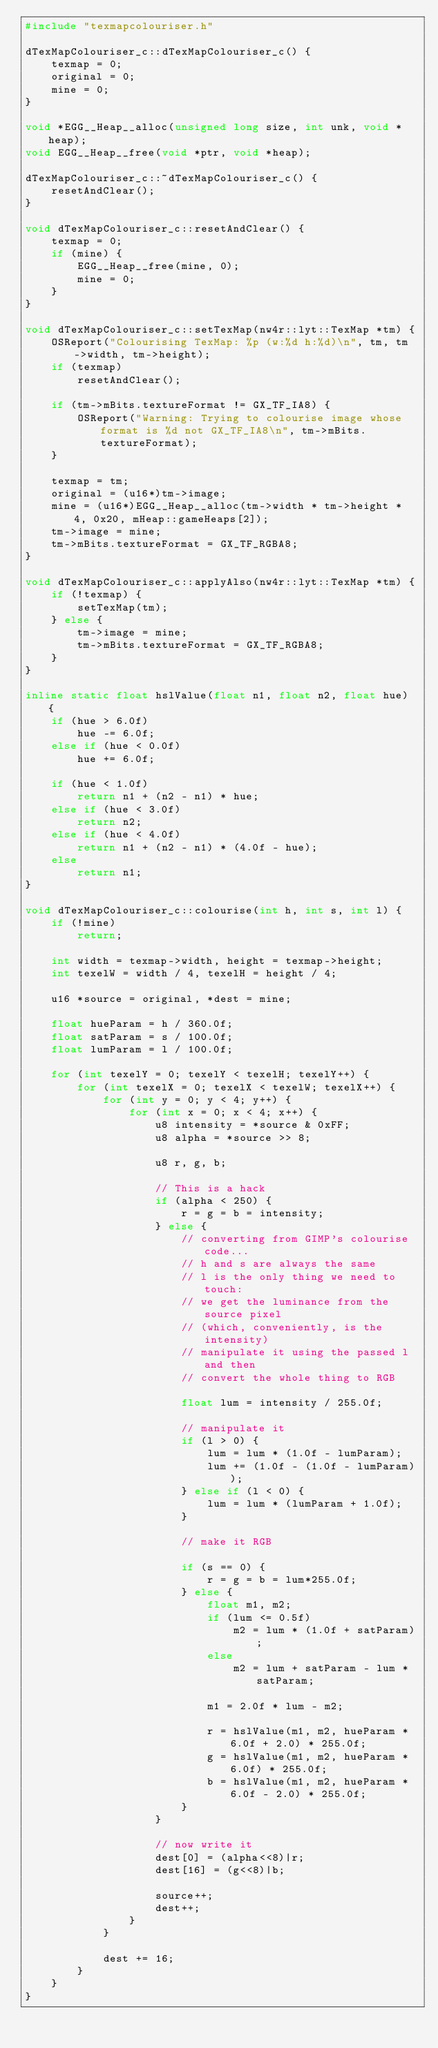<code> <loc_0><loc_0><loc_500><loc_500><_C++_>#include "texmapcolouriser.h"

dTexMapColouriser_c::dTexMapColouriser_c() {
	texmap = 0;
	original = 0;
	mine = 0;
}

void *EGG__Heap__alloc(unsigned long size, int unk, void *heap);
void EGG__Heap__free(void *ptr, void *heap);

dTexMapColouriser_c::~dTexMapColouriser_c() {
	resetAndClear();
}

void dTexMapColouriser_c::resetAndClear() {
	texmap = 0;
	if (mine) {
		EGG__Heap__free(mine, 0);
		mine = 0;
	}
}

void dTexMapColouriser_c::setTexMap(nw4r::lyt::TexMap *tm) {
	OSReport("Colourising TexMap: %p (w:%d h:%d)\n", tm, tm->width, tm->height);
	if (texmap)
		resetAndClear();

	if (tm->mBits.textureFormat != GX_TF_IA8) {
		OSReport("Warning: Trying to colourise image whose format is %d not GX_TF_IA8\n", tm->mBits.textureFormat);
	}

	texmap = tm;
	original = (u16*)tm->image;
	mine = (u16*)EGG__Heap__alloc(tm->width * tm->height * 4, 0x20, mHeap::gameHeaps[2]);
	tm->image = mine;
	tm->mBits.textureFormat = GX_TF_RGBA8;
}

void dTexMapColouriser_c::applyAlso(nw4r::lyt::TexMap *tm) {
	if (!texmap) {
		setTexMap(tm);
	} else {
		tm->image = mine;
		tm->mBits.textureFormat = GX_TF_RGBA8;
	}
}

inline static float hslValue(float n1, float n2, float hue) {
	if (hue > 6.0f)
		hue -= 6.0f;
	else if (hue < 0.0f)
		hue += 6.0f;

	if (hue < 1.0f)
		return n1 + (n2 - n1) * hue;
	else if (hue < 3.0f)
		return n2;
	else if (hue < 4.0f)
		return n1 + (n2 - n1) * (4.0f - hue);
	else
		return n1;
}

void dTexMapColouriser_c::colourise(int h, int s, int l) {
	if (!mine)
		return;

	int width = texmap->width, height = texmap->height;
	int texelW = width / 4, texelH = height / 4;

	u16 *source = original, *dest = mine;

	float hueParam = h / 360.0f;
	float satParam = s / 100.0f;
	float lumParam = l / 100.0f;

	for (int texelY = 0; texelY < texelH; texelY++) {
		for (int texelX = 0; texelX < texelW; texelX++) {
			for (int y = 0; y < 4; y++) {
				for (int x = 0; x < 4; x++) {
					u8 intensity = *source & 0xFF;
					u8 alpha = *source >> 8;

					u8 r, g, b;

					// This is a hack
					if (alpha < 250) {
						r = g = b = intensity;
					} else {
						// converting from GIMP's colourise code...
						// h and s are always the same
						// l is the only thing we need to touch:
						// we get the luminance from the source pixel
						// (which, conveniently, is the intensity)
						// manipulate it using the passed l and then
						// convert the whole thing to RGB

						float lum = intensity / 255.0f;

						// manipulate it
						if (l > 0) {
							lum = lum * (1.0f - lumParam);
							lum += (1.0f - (1.0f - lumParam));
						} else if (l < 0) {
							lum = lum * (lumParam + 1.0f);
						}

						// make it RGB

						if (s == 0) {
							r = g = b = lum*255.0f;
						} else {
							float m1, m2;
							if (lum <= 0.5f)
								m2 = lum * (1.0f + satParam);
							else
								m2 = lum + satParam - lum * satParam;

							m1 = 2.0f * lum - m2;

							r = hslValue(m1, m2, hueParam * 6.0f + 2.0) * 255.0f;
							g = hslValue(m1, m2, hueParam * 6.0f) * 255.0f;
							b = hslValue(m1, m2, hueParam * 6.0f - 2.0) * 255.0f;
						}
					}

					// now write it
					dest[0] = (alpha<<8)|r;
					dest[16] = (g<<8)|b;

					source++;
					dest++;
				}
			}

			dest += 16;
		}
	}
}


</code> 